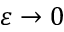<formula> <loc_0><loc_0><loc_500><loc_500>\varepsilon \to 0</formula> 